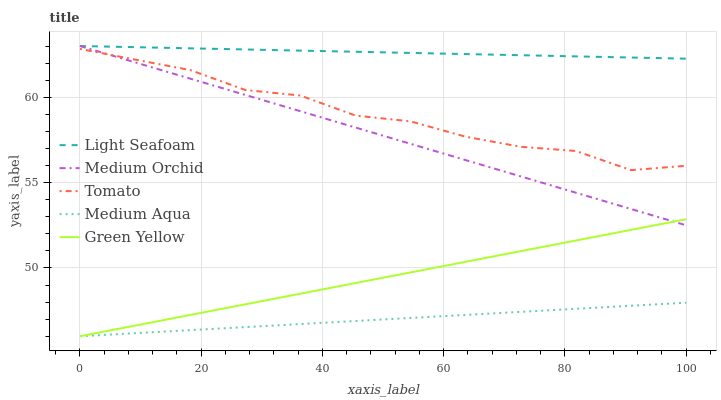Does Medium Aqua have the minimum area under the curve?
Answer yes or no. Yes. Does Light Seafoam have the maximum area under the curve?
Answer yes or no. Yes. Does Medium Orchid have the minimum area under the curve?
Answer yes or no. No. Does Medium Orchid have the maximum area under the curve?
Answer yes or no. No. Is Medium Orchid the smoothest?
Answer yes or no. Yes. Is Tomato the roughest?
Answer yes or no. Yes. Is Light Seafoam the smoothest?
Answer yes or no. No. Is Light Seafoam the roughest?
Answer yes or no. No. Does Medium Aqua have the lowest value?
Answer yes or no. Yes. Does Medium Orchid have the lowest value?
Answer yes or no. No. Does Light Seafoam have the highest value?
Answer yes or no. Yes. Does Medium Aqua have the highest value?
Answer yes or no. No. Is Medium Aqua less than Medium Orchid?
Answer yes or no. Yes. Is Tomato greater than Medium Aqua?
Answer yes or no. Yes. Does Medium Orchid intersect Tomato?
Answer yes or no. Yes. Is Medium Orchid less than Tomato?
Answer yes or no. No. Is Medium Orchid greater than Tomato?
Answer yes or no. No. Does Medium Aqua intersect Medium Orchid?
Answer yes or no. No. 